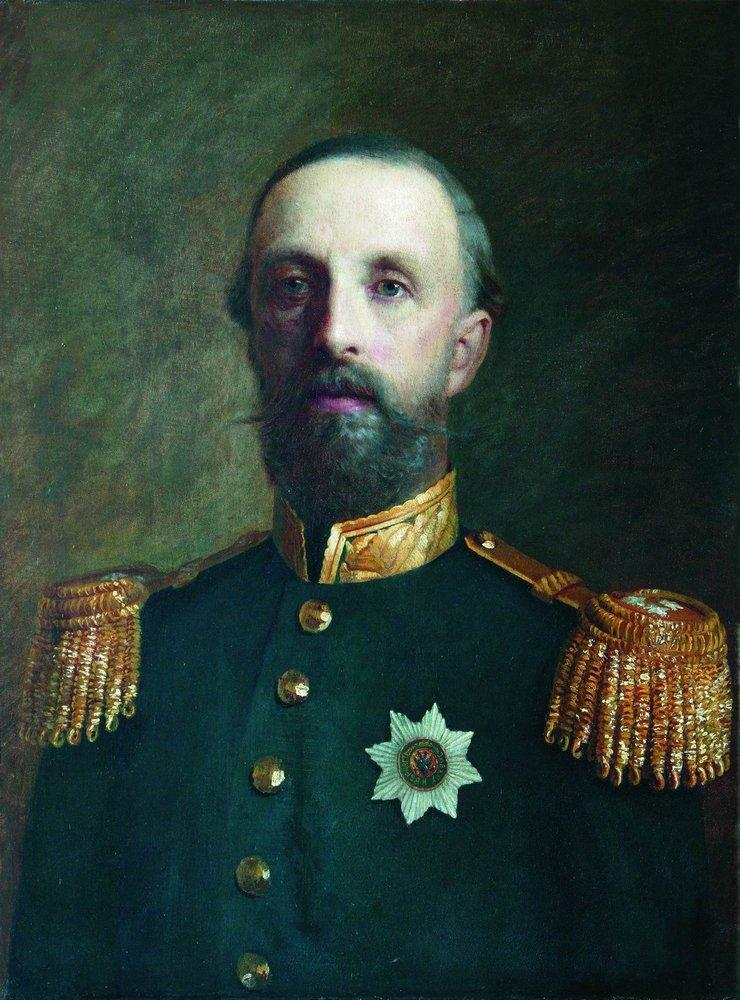What is this photo about? The image is a portrait of a man clad in a distinguished military uniform. He sports a long beard and mustache, giving him a dignified appearance. His navy blue jacket is embellished with gold epaulettes, indicating his high rank, and a prominent white star on his chest signifies his achievements and honors. The background is a muted, somber brown which contrasts sharply with the detailed and realistic depiction of the man, adding depth to the image. The portrait exudes a sense of authority and respect, encapsulating the man's esteemed position within the military. 